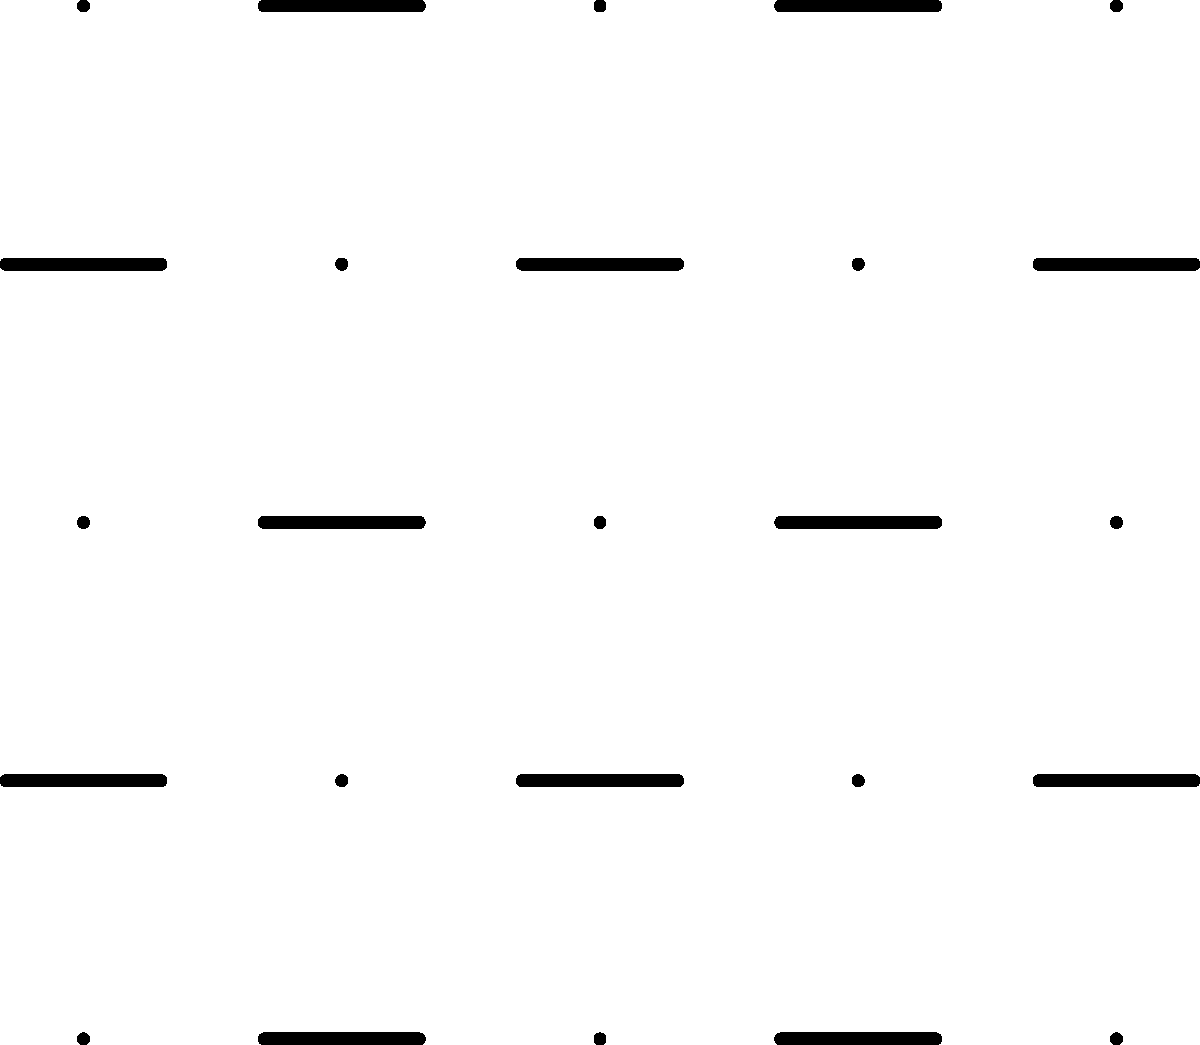Analyze the 5x5 grid pattern of dots and dashes shown above. Assuming this is a binary signal where dots represent 0 and dashes represent 1, what decimal number does this pattern encode when read row by row from top to bottom, left to right? To decode this binary signal, we'll follow these steps:

1. Read the grid row by row, assigning 0 to dots and 1 to dashes.
2. Convert the resulting binary number to decimal.

Reading the grid:
Row 1: 0 1 0 1 0
Row 2: 1 0 1 0 1
Row 3: 0 1 0 1 0
Row 4: 1 0 1 0 1
Row 5: 0 1 0 1 0

Combining these rows, we get the binary number:
0101010101010101010101010

To convert this to decimal:

$$(0 \times 2^{24}) + (1 \times 2^{23}) + (0 \times 2^{22}) + ... + (1 \times 2^1) + (0 \times 2^0)$$

$$ = 2^{23} + 2^{21} + 2^{19} + 2^{17} + 2^{15} + 2^{13} + 2^{11} + 2^9 + 2^7 + 2^5 + 2^3 + 2^1$$

$$ = 8388608 + 2097152 + 524288 + 131072 + 32768 + 8192 + 2048 + 512 + 128 + 32 + 8 + 2$$

$$ = 11184810$$

Therefore, the decimal number encoded in this binary signal is 11184810.
Answer: 11184810 